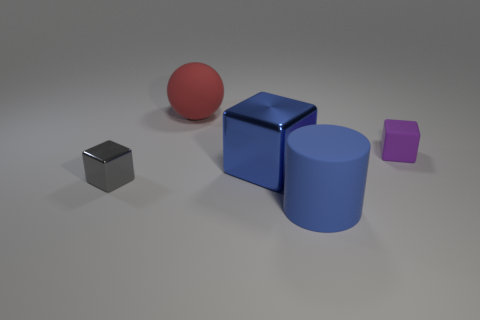Is the number of red blocks less than the number of big blue metallic blocks? Indeed, the number of red blocks, which is one, is less than the number of large blue metallic blocks, which are two in the image. 